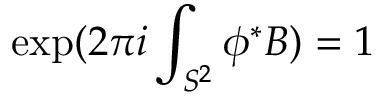<formula> <loc_0><loc_0><loc_500><loc_500>\exp ( 2 \pi i \int _ { S ^ { 2 } } \phi ^ { * } { B } ) = 1</formula> 